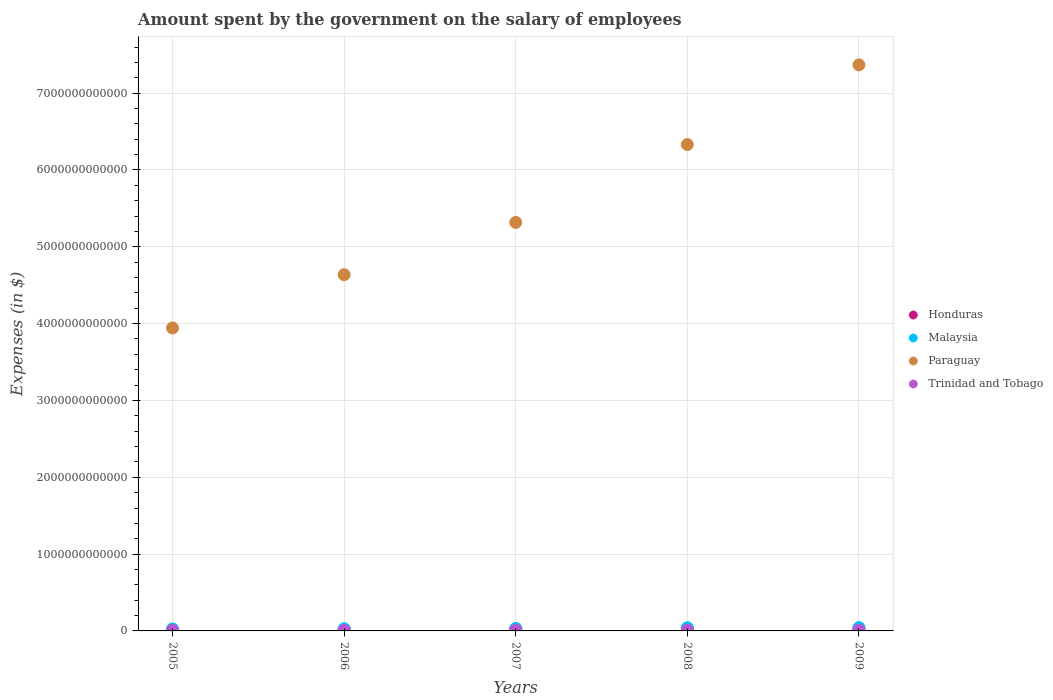Is the number of dotlines equal to the number of legend labels?
Your response must be concise. Yes. What is the amount spent on the salary of employees by the government in Trinidad and Tobago in 2009?
Offer a terse response. 1.02e+1. Across all years, what is the maximum amount spent on the salary of employees by the government in Honduras?
Offer a terse response. 3.50e+1. Across all years, what is the minimum amount spent on the salary of employees by the government in Trinidad and Tobago?
Your response must be concise. 7.18e+09. In which year was the amount spent on the salary of employees by the government in Malaysia maximum?
Your response must be concise. 2009. What is the total amount spent on the salary of employees by the government in Paraguay in the graph?
Provide a succinct answer. 2.76e+13. What is the difference between the amount spent on the salary of employees by the government in Honduras in 2005 and that in 2007?
Make the answer very short. -7.49e+09. What is the difference between the amount spent on the salary of employees by the government in Malaysia in 2008 and the amount spent on the salary of employees by the government in Paraguay in 2009?
Your answer should be compact. -7.33e+12. What is the average amount spent on the salary of employees by the government in Paraguay per year?
Offer a terse response. 5.52e+12. In the year 2009, what is the difference between the amount spent on the salary of employees by the government in Trinidad and Tobago and amount spent on the salary of employees by the government in Paraguay?
Your response must be concise. -7.36e+12. What is the ratio of the amount spent on the salary of employees by the government in Honduras in 2006 to that in 2009?
Make the answer very short. 0.58. Is the amount spent on the salary of employees by the government in Trinidad and Tobago in 2005 less than that in 2008?
Ensure brevity in your answer.  Yes. Is the difference between the amount spent on the salary of employees by the government in Trinidad and Tobago in 2007 and 2009 greater than the difference between the amount spent on the salary of employees by the government in Paraguay in 2007 and 2009?
Make the answer very short. Yes. What is the difference between the highest and the second highest amount spent on the salary of employees by the government in Trinidad and Tobago?
Your answer should be compact. 2.80e+08. What is the difference between the highest and the lowest amount spent on the salary of employees by the government in Malaysia?
Give a very brief answer. 1.72e+1. Is the sum of the amount spent on the salary of employees by the government in Trinidad and Tobago in 2005 and 2009 greater than the maximum amount spent on the salary of employees by the government in Malaysia across all years?
Ensure brevity in your answer.  No. Is it the case that in every year, the sum of the amount spent on the salary of employees by the government in Malaysia and amount spent on the salary of employees by the government in Trinidad and Tobago  is greater than the amount spent on the salary of employees by the government in Honduras?
Provide a short and direct response. Yes. Does the amount spent on the salary of employees by the government in Malaysia monotonically increase over the years?
Your answer should be compact. Yes. Is the amount spent on the salary of employees by the government in Honduras strictly greater than the amount spent on the salary of employees by the government in Paraguay over the years?
Keep it short and to the point. No. Is the amount spent on the salary of employees by the government in Malaysia strictly less than the amount spent on the salary of employees by the government in Trinidad and Tobago over the years?
Make the answer very short. No. What is the difference between two consecutive major ticks on the Y-axis?
Ensure brevity in your answer.  1.00e+12. Are the values on the major ticks of Y-axis written in scientific E-notation?
Offer a very short reply. No. Does the graph contain any zero values?
Your answer should be compact. No. Does the graph contain grids?
Offer a very short reply. Yes. Where does the legend appear in the graph?
Offer a very short reply. Center right. How many legend labels are there?
Provide a succinct answer. 4. How are the legend labels stacked?
Make the answer very short. Vertical. What is the title of the graph?
Make the answer very short. Amount spent by the government on the salary of employees. Does "Libya" appear as one of the legend labels in the graph?
Your answer should be very brief. No. What is the label or title of the X-axis?
Ensure brevity in your answer.  Years. What is the label or title of the Y-axis?
Ensure brevity in your answer.  Expenses (in $). What is the Expenses (in $) in Honduras in 2005?
Your answer should be very brief. 1.80e+1. What is the Expenses (in $) of Malaysia in 2005?
Your response must be concise. 2.56e+1. What is the Expenses (in $) in Paraguay in 2005?
Give a very brief answer. 3.94e+12. What is the Expenses (in $) in Trinidad and Tobago in 2005?
Provide a short and direct response. 7.18e+09. What is the Expenses (in $) of Honduras in 2006?
Your response must be concise. 2.04e+1. What is the Expenses (in $) in Malaysia in 2006?
Keep it short and to the point. 2.85e+1. What is the Expenses (in $) in Paraguay in 2006?
Your answer should be compact. 4.64e+12. What is the Expenses (in $) in Trinidad and Tobago in 2006?
Give a very brief answer. 7.43e+09. What is the Expenses (in $) in Honduras in 2007?
Offer a terse response. 2.55e+1. What is the Expenses (in $) in Malaysia in 2007?
Keep it short and to the point. 3.26e+1. What is the Expenses (in $) of Paraguay in 2007?
Offer a very short reply. 5.32e+12. What is the Expenses (in $) in Trinidad and Tobago in 2007?
Give a very brief answer. 8.81e+09. What is the Expenses (in $) of Honduras in 2008?
Your answer should be compact. 2.92e+1. What is the Expenses (in $) of Malaysia in 2008?
Provide a short and direct response. 4.10e+1. What is the Expenses (in $) in Paraguay in 2008?
Give a very brief answer. 6.33e+12. What is the Expenses (in $) in Trinidad and Tobago in 2008?
Your answer should be very brief. 9.96e+09. What is the Expenses (in $) in Honduras in 2009?
Keep it short and to the point. 3.50e+1. What is the Expenses (in $) of Malaysia in 2009?
Provide a succinct answer. 4.28e+1. What is the Expenses (in $) of Paraguay in 2009?
Keep it short and to the point. 7.37e+12. What is the Expenses (in $) in Trinidad and Tobago in 2009?
Keep it short and to the point. 1.02e+1. Across all years, what is the maximum Expenses (in $) of Honduras?
Your answer should be compact. 3.50e+1. Across all years, what is the maximum Expenses (in $) in Malaysia?
Offer a terse response. 4.28e+1. Across all years, what is the maximum Expenses (in $) of Paraguay?
Provide a short and direct response. 7.37e+12. Across all years, what is the maximum Expenses (in $) in Trinidad and Tobago?
Offer a very short reply. 1.02e+1. Across all years, what is the minimum Expenses (in $) in Honduras?
Your response must be concise. 1.80e+1. Across all years, what is the minimum Expenses (in $) in Malaysia?
Your answer should be very brief. 2.56e+1. Across all years, what is the minimum Expenses (in $) of Paraguay?
Your response must be concise. 3.94e+12. Across all years, what is the minimum Expenses (in $) in Trinidad and Tobago?
Ensure brevity in your answer.  7.18e+09. What is the total Expenses (in $) in Honduras in the graph?
Your response must be concise. 1.28e+11. What is the total Expenses (in $) in Malaysia in the graph?
Keep it short and to the point. 1.70e+11. What is the total Expenses (in $) of Paraguay in the graph?
Provide a succinct answer. 2.76e+13. What is the total Expenses (in $) of Trinidad and Tobago in the graph?
Keep it short and to the point. 4.36e+1. What is the difference between the Expenses (in $) in Honduras in 2005 and that in 2006?
Your answer should be very brief. -2.36e+09. What is the difference between the Expenses (in $) in Malaysia in 2005 and that in 2006?
Offer a terse response. -2.93e+09. What is the difference between the Expenses (in $) in Paraguay in 2005 and that in 2006?
Your answer should be compact. -6.94e+11. What is the difference between the Expenses (in $) in Trinidad and Tobago in 2005 and that in 2006?
Make the answer very short. -2.56e+08. What is the difference between the Expenses (in $) in Honduras in 2005 and that in 2007?
Give a very brief answer. -7.49e+09. What is the difference between the Expenses (in $) of Malaysia in 2005 and that in 2007?
Your answer should be very brief. -7.00e+09. What is the difference between the Expenses (in $) of Paraguay in 2005 and that in 2007?
Make the answer very short. -1.37e+12. What is the difference between the Expenses (in $) of Trinidad and Tobago in 2005 and that in 2007?
Offer a terse response. -1.64e+09. What is the difference between the Expenses (in $) in Honduras in 2005 and that in 2008?
Keep it short and to the point. -1.11e+1. What is the difference between the Expenses (in $) of Malaysia in 2005 and that in 2008?
Your response must be concise. -1.54e+1. What is the difference between the Expenses (in $) of Paraguay in 2005 and that in 2008?
Make the answer very short. -2.39e+12. What is the difference between the Expenses (in $) of Trinidad and Tobago in 2005 and that in 2008?
Keep it short and to the point. -2.78e+09. What is the difference between the Expenses (in $) of Honduras in 2005 and that in 2009?
Ensure brevity in your answer.  -1.70e+1. What is the difference between the Expenses (in $) in Malaysia in 2005 and that in 2009?
Your response must be concise. -1.72e+1. What is the difference between the Expenses (in $) in Paraguay in 2005 and that in 2009?
Give a very brief answer. -3.42e+12. What is the difference between the Expenses (in $) of Trinidad and Tobago in 2005 and that in 2009?
Provide a short and direct response. -3.06e+09. What is the difference between the Expenses (in $) in Honduras in 2006 and that in 2007?
Your answer should be compact. -5.13e+09. What is the difference between the Expenses (in $) in Malaysia in 2006 and that in 2007?
Give a very brief answer. -4.07e+09. What is the difference between the Expenses (in $) of Paraguay in 2006 and that in 2007?
Your answer should be very brief. -6.80e+11. What is the difference between the Expenses (in $) in Trinidad and Tobago in 2006 and that in 2007?
Your response must be concise. -1.38e+09. What is the difference between the Expenses (in $) of Honduras in 2006 and that in 2008?
Your response must be concise. -8.79e+09. What is the difference between the Expenses (in $) in Malaysia in 2006 and that in 2008?
Your response must be concise. -1.25e+1. What is the difference between the Expenses (in $) in Paraguay in 2006 and that in 2008?
Your answer should be very brief. -1.69e+12. What is the difference between the Expenses (in $) of Trinidad and Tobago in 2006 and that in 2008?
Make the answer very short. -2.52e+09. What is the difference between the Expenses (in $) in Honduras in 2006 and that in 2009?
Ensure brevity in your answer.  -1.46e+1. What is the difference between the Expenses (in $) of Malaysia in 2006 and that in 2009?
Provide a short and direct response. -1.43e+1. What is the difference between the Expenses (in $) in Paraguay in 2006 and that in 2009?
Make the answer very short. -2.73e+12. What is the difference between the Expenses (in $) in Trinidad and Tobago in 2006 and that in 2009?
Your response must be concise. -2.80e+09. What is the difference between the Expenses (in $) in Honduras in 2007 and that in 2008?
Keep it short and to the point. -3.66e+09. What is the difference between the Expenses (in $) of Malaysia in 2007 and that in 2008?
Offer a very short reply. -8.42e+09. What is the difference between the Expenses (in $) in Paraguay in 2007 and that in 2008?
Provide a succinct answer. -1.01e+12. What is the difference between the Expenses (in $) in Trinidad and Tobago in 2007 and that in 2008?
Make the answer very short. -1.14e+09. What is the difference between the Expenses (in $) in Honduras in 2007 and that in 2009?
Your response must be concise. -9.50e+09. What is the difference between the Expenses (in $) of Malaysia in 2007 and that in 2009?
Your answer should be compact. -1.02e+1. What is the difference between the Expenses (in $) of Paraguay in 2007 and that in 2009?
Your answer should be very brief. -2.05e+12. What is the difference between the Expenses (in $) of Trinidad and Tobago in 2007 and that in 2009?
Make the answer very short. -1.42e+09. What is the difference between the Expenses (in $) in Honduras in 2008 and that in 2009?
Keep it short and to the point. -5.85e+09. What is the difference between the Expenses (in $) in Malaysia in 2008 and that in 2009?
Give a very brief answer. -1.77e+09. What is the difference between the Expenses (in $) of Paraguay in 2008 and that in 2009?
Your answer should be compact. -1.04e+12. What is the difference between the Expenses (in $) in Trinidad and Tobago in 2008 and that in 2009?
Your answer should be compact. -2.80e+08. What is the difference between the Expenses (in $) of Honduras in 2005 and the Expenses (in $) of Malaysia in 2006?
Make the answer very short. -1.05e+1. What is the difference between the Expenses (in $) in Honduras in 2005 and the Expenses (in $) in Paraguay in 2006?
Your response must be concise. -4.62e+12. What is the difference between the Expenses (in $) of Honduras in 2005 and the Expenses (in $) of Trinidad and Tobago in 2006?
Make the answer very short. 1.06e+1. What is the difference between the Expenses (in $) of Malaysia in 2005 and the Expenses (in $) of Paraguay in 2006?
Offer a very short reply. -4.61e+12. What is the difference between the Expenses (in $) in Malaysia in 2005 and the Expenses (in $) in Trinidad and Tobago in 2006?
Offer a very short reply. 1.82e+1. What is the difference between the Expenses (in $) in Paraguay in 2005 and the Expenses (in $) in Trinidad and Tobago in 2006?
Make the answer very short. 3.94e+12. What is the difference between the Expenses (in $) in Honduras in 2005 and the Expenses (in $) in Malaysia in 2007?
Your answer should be very brief. -1.45e+1. What is the difference between the Expenses (in $) in Honduras in 2005 and the Expenses (in $) in Paraguay in 2007?
Your answer should be compact. -5.30e+12. What is the difference between the Expenses (in $) of Honduras in 2005 and the Expenses (in $) of Trinidad and Tobago in 2007?
Your answer should be very brief. 9.22e+09. What is the difference between the Expenses (in $) in Malaysia in 2005 and the Expenses (in $) in Paraguay in 2007?
Your answer should be compact. -5.29e+12. What is the difference between the Expenses (in $) in Malaysia in 2005 and the Expenses (in $) in Trinidad and Tobago in 2007?
Ensure brevity in your answer.  1.68e+1. What is the difference between the Expenses (in $) in Paraguay in 2005 and the Expenses (in $) in Trinidad and Tobago in 2007?
Provide a succinct answer. 3.93e+12. What is the difference between the Expenses (in $) of Honduras in 2005 and the Expenses (in $) of Malaysia in 2008?
Provide a short and direct response. -2.30e+1. What is the difference between the Expenses (in $) of Honduras in 2005 and the Expenses (in $) of Paraguay in 2008?
Give a very brief answer. -6.31e+12. What is the difference between the Expenses (in $) in Honduras in 2005 and the Expenses (in $) in Trinidad and Tobago in 2008?
Provide a short and direct response. 8.08e+09. What is the difference between the Expenses (in $) of Malaysia in 2005 and the Expenses (in $) of Paraguay in 2008?
Ensure brevity in your answer.  -6.31e+12. What is the difference between the Expenses (in $) of Malaysia in 2005 and the Expenses (in $) of Trinidad and Tobago in 2008?
Give a very brief answer. 1.56e+1. What is the difference between the Expenses (in $) of Paraguay in 2005 and the Expenses (in $) of Trinidad and Tobago in 2008?
Ensure brevity in your answer.  3.93e+12. What is the difference between the Expenses (in $) in Honduras in 2005 and the Expenses (in $) in Malaysia in 2009?
Ensure brevity in your answer.  -2.47e+1. What is the difference between the Expenses (in $) of Honduras in 2005 and the Expenses (in $) of Paraguay in 2009?
Make the answer very short. -7.35e+12. What is the difference between the Expenses (in $) of Honduras in 2005 and the Expenses (in $) of Trinidad and Tobago in 2009?
Offer a terse response. 7.80e+09. What is the difference between the Expenses (in $) in Malaysia in 2005 and the Expenses (in $) in Paraguay in 2009?
Provide a succinct answer. -7.34e+12. What is the difference between the Expenses (in $) in Malaysia in 2005 and the Expenses (in $) in Trinidad and Tobago in 2009?
Offer a very short reply. 1.53e+1. What is the difference between the Expenses (in $) of Paraguay in 2005 and the Expenses (in $) of Trinidad and Tobago in 2009?
Your response must be concise. 3.93e+12. What is the difference between the Expenses (in $) of Honduras in 2006 and the Expenses (in $) of Malaysia in 2007?
Provide a short and direct response. -1.22e+1. What is the difference between the Expenses (in $) in Honduras in 2006 and the Expenses (in $) in Paraguay in 2007?
Provide a short and direct response. -5.30e+12. What is the difference between the Expenses (in $) in Honduras in 2006 and the Expenses (in $) in Trinidad and Tobago in 2007?
Provide a succinct answer. 1.16e+1. What is the difference between the Expenses (in $) in Malaysia in 2006 and the Expenses (in $) in Paraguay in 2007?
Ensure brevity in your answer.  -5.29e+12. What is the difference between the Expenses (in $) of Malaysia in 2006 and the Expenses (in $) of Trinidad and Tobago in 2007?
Make the answer very short. 1.97e+1. What is the difference between the Expenses (in $) of Paraguay in 2006 and the Expenses (in $) of Trinidad and Tobago in 2007?
Make the answer very short. 4.63e+12. What is the difference between the Expenses (in $) of Honduras in 2006 and the Expenses (in $) of Malaysia in 2008?
Give a very brief answer. -2.06e+1. What is the difference between the Expenses (in $) of Honduras in 2006 and the Expenses (in $) of Paraguay in 2008?
Your response must be concise. -6.31e+12. What is the difference between the Expenses (in $) in Honduras in 2006 and the Expenses (in $) in Trinidad and Tobago in 2008?
Offer a terse response. 1.04e+1. What is the difference between the Expenses (in $) of Malaysia in 2006 and the Expenses (in $) of Paraguay in 2008?
Ensure brevity in your answer.  -6.30e+12. What is the difference between the Expenses (in $) in Malaysia in 2006 and the Expenses (in $) in Trinidad and Tobago in 2008?
Your answer should be very brief. 1.86e+1. What is the difference between the Expenses (in $) in Paraguay in 2006 and the Expenses (in $) in Trinidad and Tobago in 2008?
Provide a short and direct response. 4.63e+12. What is the difference between the Expenses (in $) of Honduras in 2006 and the Expenses (in $) of Malaysia in 2009?
Offer a terse response. -2.24e+1. What is the difference between the Expenses (in $) of Honduras in 2006 and the Expenses (in $) of Paraguay in 2009?
Offer a terse response. -7.35e+12. What is the difference between the Expenses (in $) in Honduras in 2006 and the Expenses (in $) in Trinidad and Tobago in 2009?
Your answer should be compact. 1.02e+1. What is the difference between the Expenses (in $) of Malaysia in 2006 and the Expenses (in $) of Paraguay in 2009?
Provide a succinct answer. -7.34e+12. What is the difference between the Expenses (in $) in Malaysia in 2006 and the Expenses (in $) in Trinidad and Tobago in 2009?
Ensure brevity in your answer.  1.83e+1. What is the difference between the Expenses (in $) in Paraguay in 2006 and the Expenses (in $) in Trinidad and Tobago in 2009?
Your answer should be compact. 4.63e+12. What is the difference between the Expenses (in $) of Honduras in 2007 and the Expenses (in $) of Malaysia in 2008?
Your answer should be compact. -1.55e+1. What is the difference between the Expenses (in $) in Honduras in 2007 and the Expenses (in $) in Paraguay in 2008?
Give a very brief answer. -6.31e+12. What is the difference between the Expenses (in $) of Honduras in 2007 and the Expenses (in $) of Trinidad and Tobago in 2008?
Provide a short and direct response. 1.56e+1. What is the difference between the Expenses (in $) in Malaysia in 2007 and the Expenses (in $) in Paraguay in 2008?
Your answer should be very brief. -6.30e+12. What is the difference between the Expenses (in $) of Malaysia in 2007 and the Expenses (in $) of Trinidad and Tobago in 2008?
Ensure brevity in your answer.  2.26e+1. What is the difference between the Expenses (in $) in Paraguay in 2007 and the Expenses (in $) in Trinidad and Tobago in 2008?
Offer a terse response. 5.31e+12. What is the difference between the Expenses (in $) of Honduras in 2007 and the Expenses (in $) of Malaysia in 2009?
Offer a terse response. -1.73e+1. What is the difference between the Expenses (in $) in Honduras in 2007 and the Expenses (in $) in Paraguay in 2009?
Ensure brevity in your answer.  -7.34e+12. What is the difference between the Expenses (in $) of Honduras in 2007 and the Expenses (in $) of Trinidad and Tobago in 2009?
Offer a very short reply. 1.53e+1. What is the difference between the Expenses (in $) of Malaysia in 2007 and the Expenses (in $) of Paraguay in 2009?
Provide a succinct answer. -7.34e+12. What is the difference between the Expenses (in $) in Malaysia in 2007 and the Expenses (in $) in Trinidad and Tobago in 2009?
Your answer should be very brief. 2.24e+1. What is the difference between the Expenses (in $) of Paraguay in 2007 and the Expenses (in $) of Trinidad and Tobago in 2009?
Keep it short and to the point. 5.31e+12. What is the difference between the Expenses (in $) in Honduras in 2008 and the Expenses (in $) in Malaysia in 2009?
Provide a short and direct response. -1.36e+1. What is the difference between the Expenses (in $) of Honduras in 2008 and the Expenses (in $) of Paraguay in 2009?
Make the answer very short. -7.34e+12. What is the difference between the Expenses (in $) of Honduras in 2008 and the Expenses (in $) of Trinidad and Tobago in 2009?
Your answer should be very brief. 1.89e+1. What is the difference between the Expenses (in $) in Malaysia in 2008 and the Expenses (in $) in Paraguay in 2009?
Your response must be concise. -7.33e+12. What is the difference between the Expenses (in $) in Malaysia in 2008 and the Expenses (in $) in Trinidad and Tobago in 2009?
Give a very brief answer. 3.08e+1. What is the difference between the Expenses (in $) in Paraguay in 2008 and the Expenses (in $) in Trinidad and Tobago in 2009?
Make the answer very short. 6.32e+12. What is the average Expenses (in $) in Honduras per year?
Provide a short and direct response. 2.56e+1. What is the average Expenses (in $) in Malaysia per year?
Your answer should be very brief. 3.41e+1. What is the average Expenses (in $) in Paraguay per year?
Provide a succinct answer. 5.52e+12. What is the average Expenses (in $) of Trinidad and Tobago per year?
Your response must be concise. 8.72e+09. In the year 2005, what is the difference between the Expenses (in $) of Honduras and Expenses (in $) of Malaysia?
Give a very brief answer. -7.55e+09. In the year 2005, what is the difference between the Expenses (in $) of Honduras and Expenses (in $) of Paraguay?
Offer a terse response. -3.93e+12. In the year 2005, what is the difference between the Expenses (in $) in Honduras and Expenses (in $) in Trinidad and Tobago?
Keep it short and to the point. 1.09e+1. In the year 2005, what is the difference between the Expenses (in $) of Malaysia and Expenses (in $) of Paraguay?
Provide a succinct answer. -3.92e+12. In the year 2005, what is the difference between the Expenses (in $) in Malaysia and Expenses (in $) in Trinidad and Tobago?
Your answer should be compact. 1.84e+1. In the year 2005, what is the difference between the Expenses (in $) of Paraguay and Expenses (in $) of Trinidad and Tobago?
Offer a terse response. 3.94e+12. In the year 2006, what is the difference between the Expenses (in $) of Honduras and Expenses (in $) of Malaysia?
Your answer should be very brief. -8.12e+09. In the year 2006, what is the difference between the Expenses (in $) of Honduras and Expenses (in $) of Paraguay?
Provide a short and direct response. -4.62e+12. In the year 2006, what is the difference between the Expenses (in $) of Honduras and Expenses (in $) of Trinidad and Tobago?
Provide a short and direct response. 1.30e+1. In the year 2006, what is the difference between the Expenses (in $) in Malaysia and Expenses (in $) in Paraguay?
Provide a short and direct response. -4.61e+12. In the year 2006, what is the difference between the Expenses (in $) in Malaysia and Expenses (in $) in Trinidad and Tobago?
Provide a short and direct response. 2.11e+1. In the year 2006, what is the difference between the Expenses (in $) of Paraguay and Expenses (in $) of Trinidad and Tobago?
Offer a very short reply. 4.63e+12. In the year 2007, what is the difference between the Expenses (in $) in Honduras and Expenses (in $) in Malaysia?
Make the answer very short. -7.06e+09. In the year 2007, what is the difference between the Expenses (in $) of Honduras and Expenses (in $) of Paraguay?
Your response must be concise. -5.29e+12. In the year 2007, what is the difference between the Expenses (in $) in Honduras and Expenses (in $) in Trinidad and Tobago?
Your answer should be compact. 1.67e+1. In the year 2007, what is the difference between the Expenses (in $) in Malaysia and Expenses (in $) in Paraguay?
Provide a short and direct response. -5.28e+12. In the year 2007, what is the difference between the Expenses (in $) of Malaysia and Expenses (in $) of Trinidad and Tobago?
Your answer should be compact. 2.38e+1. In the year 2007, what is the difference between the Expenses (in $) of Paraguay and Expenses (in $) of Trinidad and Tobago?
Keep it short and to the point. 5.31e+12. In the year 2008, what is the difference between the Expenses (in $) of Honduras and Expenses (in $) of Malaysia?
Your answer should be very brief. -1.18e+1. In the year 2008, what is the difference between the Expenses (in $) in Honduras and Expenses (in $) in Paraguay?
Offer a terse response. -6.30e+12. In the year 2008, what is the difference between the Expenses (in $) in Honduras and Expenses (in $) in Trinidad and Tobago?
Your response must be concise. 1.92e+1. In the year 2008, what is the difference between the Expenses (in $) in Malaysia and Expenses (in $) in Paraguay?
Offer a very short reply. -6.29e+12. In the year 2008, what is the difference between the Expenses (in $) in Malaysia and Expenses (in $) in Trinidad and Tobago?
Make the answer very short. 3.11e+1. In the year 2008, what is the difference between the Expenses (in $) of Paraguay and Expenses (in $) of Trinidad and Tobago?
Ensure brevity in your answer.  6.32e+12. In the year 2009, what is the difference between the Expenses (in $) of Honduras and Expenses (in $) of Malaysia?
Make the answer very short. -7.75e+09. In the year 2009, what is the difference between the Expenses (in $) in Honduras and Expenses (in $) in Paraguay?
Keep it short and to the point. -7.33e+12. In the year 2009, what is the difference between the Expenses (in $) of Honduras and Expenses (in $) of Trinidad and Tobago?
Make the answer very short. 2.48e+1. In the year 2009, what is the difference between the Expenses (in $) in Malaysia and Expenses (in $) in Paraguay?
Your answer should be compact. -7.33e+12. In the year 2009, what is the difference between the Expenses (in $) in Malaysia and Expenses (in $) in Trinidad and Tobago?
Your response must be concise. 3.25e+1. In the year 2009, what is the difference between the Expenses (in $) in Paraguay and Expenses (in $) in Trinidad and Tobago?
Provide a succinct answer. 7.36e+12. What is the ratio of the Expenses (in $) in Honduras in 2005 to that in 2006?
Provide a short and direct response. 0.88. What is the ratio of the Expenses (in $) in Malaysia in 2005 to that in 2006?
Ensure brevity in your answer.  0.9. What is the ratio of the Expenses (in $) in Paraguay in 2005 to that in 2006?
Ensure brevity in your answer.  0.85. What is the ratio of the Expenses (in $) of Trinidad and Tobago in 2005 to that in 2006?
Offer a terse response. 0.97. What is the ratio of the Expenses (in $) in Honduras in 2005 to that in 2007?
Make the answer very short. 0.71. What is the ratio of the Expenses (in $) of Malaysia in 2005 to that in 2007?
Your response must be concise. 0.79. What is the ratio of the Expenses (in $) of Paraguay in 2005 to that in 2007?
Offer a very short reply. 0.74. What is the ratio of the Expenses (in $) in Trinidad and Tobago in 2005 to that in 2007?
Your answer should be very brief. 0.81. What is the ratio of the Expenses (in $) in Honduras in 2005 to that in 2008?
Give a very brief answer. 0.62. What is the ratio of the Expenses (in $) of Malaysia in 2005 to that in 2008?
Your response must be concise. 0.62. What is the ratio of the Expenses (in $) in Paraguay in 2005 to that in 2008?
Ensure brevity in your answer.  0.62. What is the ratio of the Expenses (in $) of Trinidad and Tobago in 2005 to that in 2008?
Provide a short and direct response. 0.72. What is the ratio of the Expenses (in $) of Honduras in 2005 to that in 2009?
Ensure brevity in your answer.  0.52. What is the ratio of the Expenses (in $) in Malaysia in 2005 to that in 2009?
Offer a terse response. 0.6. What is the ratio of the Expenses (in $) in Paraguay in 2005 to that in 2009?
Make the answer very short. 0.54. What is the ratio of the Expenses (in $) in Trinidad and Tobago in 2005 to that in 2009?
Your response must be concise. 0.7. What is the ratio of the Expenses (in $) of Honduras in 2006 to that in 2007?
Your answer should be compact. 0.8. What is the ratio of the Expenses (in $) of Malaysia in 2006 to that in 2007?
Provide a succinct answer. 0.88. What is the ratio of the Expenses (in $) in Paraguay in 2006 to that in 2007?
Your answer should be very brief. 0.87. What is the ratio of the Expenses (in $) in Trinidad and Tobago in 2006 to that in 2007?
Provide a short and direct response. 0.84. What is the ratio of the Expenses (in $) in Honduras in 2006 to that in 2008?
Provide a succinct answer. 0.7. What is the ratio of the Expenses (in $) of Malaysia in 2006 to that in 2008?
Your response must be concise. 0.7. What is the ratio of the Expenses (in $) of Paraguay in 2006 to that in 2008?
Your response must be concise. 0.73. What is the ratio of the Expenses (in $) of Trinidad and Tobago in 2006 to that in 2008?
Your answer should be compact. 0.75. What is the ratio of the Expenses (in $) in Honduras in 2006 to that in 2009?
Ensure brevity in your answer.  0.58. What is the ratio of the Expenses (in $) in Malaysia in 2006 to that in 2009?
Provide a succinct answer. 0.67. What is the ratio of the Expenses (in $) in Paraguay in 2006 to that in 2009?
Provide a short and direct response. 0.63. What is the ratio of the Expenses (in $) of Trinidad and Tobago in 2006 to that in 2009?
Make the answer very short. 0.73. What is the ratio of the Expenses (in $) of Honduras in 2007 to that in 2008?
Provide a short and direct response. 0.87. What is the ratio of the Expenses (in $) of Malaysia in 2007 to that in 2008?
Make the answer very short. 0.79. What is the ratio of the Expenses (in $) in Paraguay in 2007 to that in 2008?
Ensure brevity in your answer.  0.84. What is the ratio of the Expenses (in $) in Trinidad and Tobago in 2007 to that in 2008?
Give a very brief answer. 0.89. What is the ratio of the Expenses (in $) of Honduras in 2007 to that in 2009?
Make the answer very short. 0.73. What is the ratio of the Expenses (in $) in Malaysia in 2007 to that in 2009?
Provide a short and direct response. 0.76. What is the ratio of the Expenses (in $) of Paraguay in 2007 to that in 2009?
Your answer should be very brief. 0.72. What is the ratio of the Expenses (in $) of Trinidad and Tobago in 2007 to that in 2009?
Offer a terse response. 0.86. What is the ratio of the Expenses (in $) of Honduras in 2008 to that in 2009?
Your answer should be very brief. 0.83. What is the ratio of the Expenses (in $) in Malaysia in 2008 to that in 2009?
Give a very brief answer. 0.96. What is the ratio of the Expenses (in $) of Paraguay in 2008 to that in 2009?
Ensure brevity in your answer.  0.86. What is the ratio of the Expenses (in $) of Trinidad and Tobago in 2008 to that in 2009?
Offer a terse response. 0.97. What is the difference between the highest and the second highest Expenses (in $) in Honduras?
Give a very brief answer. 5.85e+09. What is the difference between the highest and the second highest Expenses (in $) of Malaysia?
Keep it short and to the point. 1.77e+09. What is the difference between the highest and the second highest Expenses (in $) in Paraguay?
Make the answer very short. 1.04e+12. What is the difference between the highest and the second highest Expenses (in $) of Trinidad and Tobago?
Your answer should be very brief. 2.80e+08. What is the difference between the highest and the lowest Expenses (in $) of Honduras?
Your answer should be very brief. 1.70e+1. What is the difference between the highest and the lowest Expenses (in $) in Malaysia?
Provide a succinct answer. 1.72e+1. What is the difference between the highest and the lowest Expenses (in $) of Paraguay?
Your answer should be compact. 3.42e+12. What is the difference between the highest and the lowest Expenses (in $) of Trinidad and Tobago?
Provide a succinct answer. 3.06e+09. 